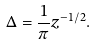Convert formula to latex. <formula><loc_0><loc_0><loc_500><loc_500>\Delta = \frac { 1 } { \pi } z ^ { - 1 / 2 } .</formula> 